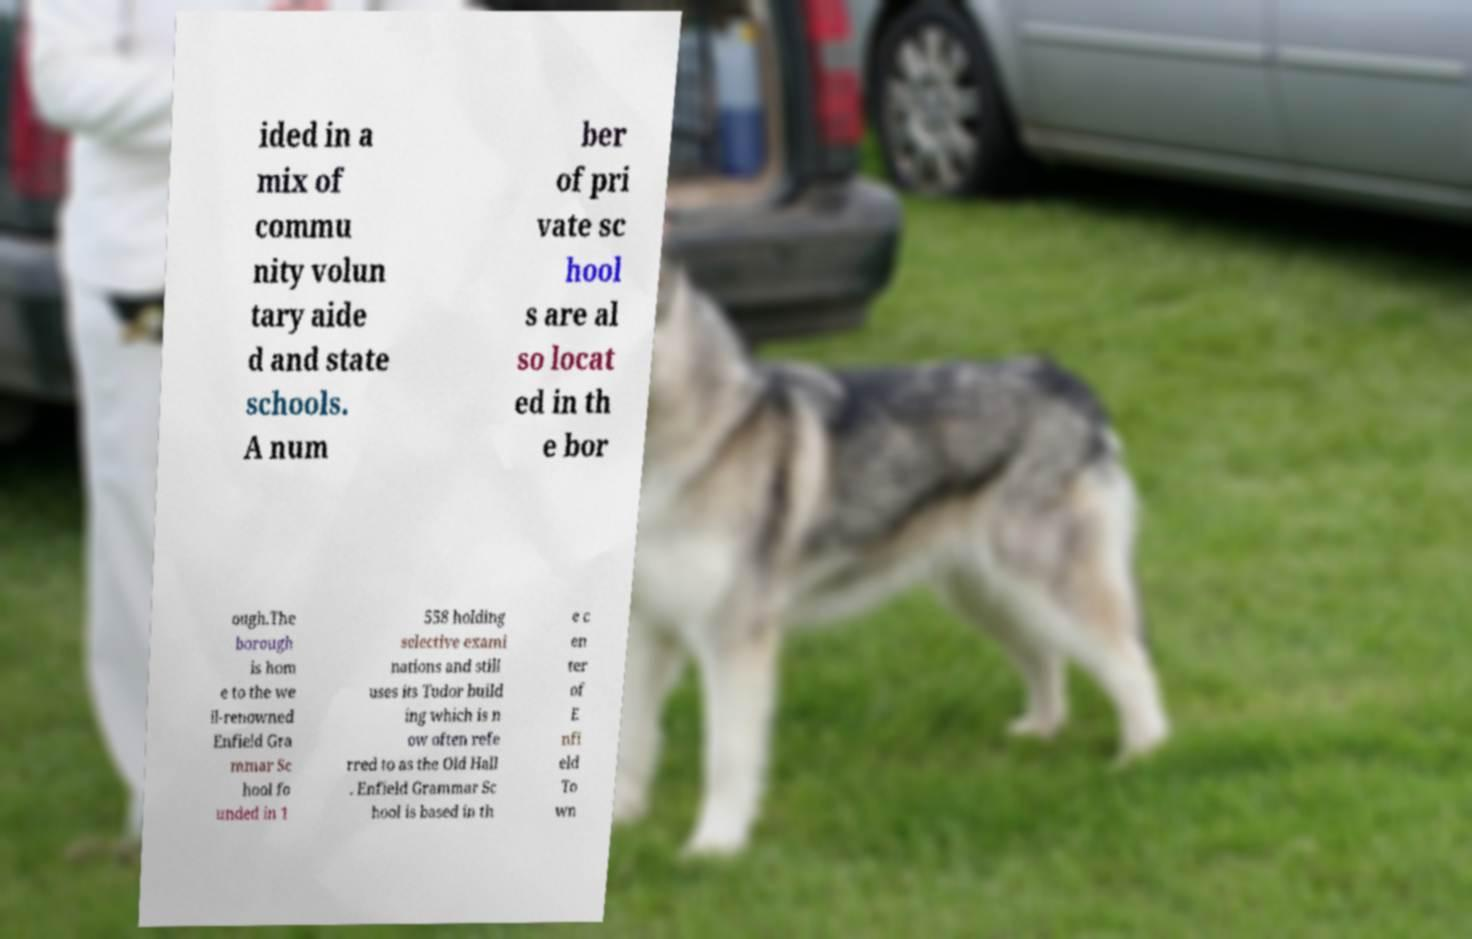Please identify and transcribe the text found in this image. ided in a mix of commu nity volun tary aide d and state schools. A num ber of pri vate sc hool s are al so locat ed in th e bor ough.The borough is hom e to the we ll-renowned Enfield Gra mmar Sc hool fo unded in 1 558 holding selective exami nations and still uses its Tudor build ing which is n ow often refe rred to as the Old Hall . Enfield Grammar Sc hool is based in th e c en ter of E nfi eld To wn 